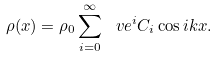Convert formula to latex. <formula><loc_0><loc_0><loc_500><loc_500>\rho ( x ) = \rho _ { 0 } \sum _ { i = 0 } ^ { \infty } \ v e ^ { i } C _ { i } \cos i k x .</formula> 